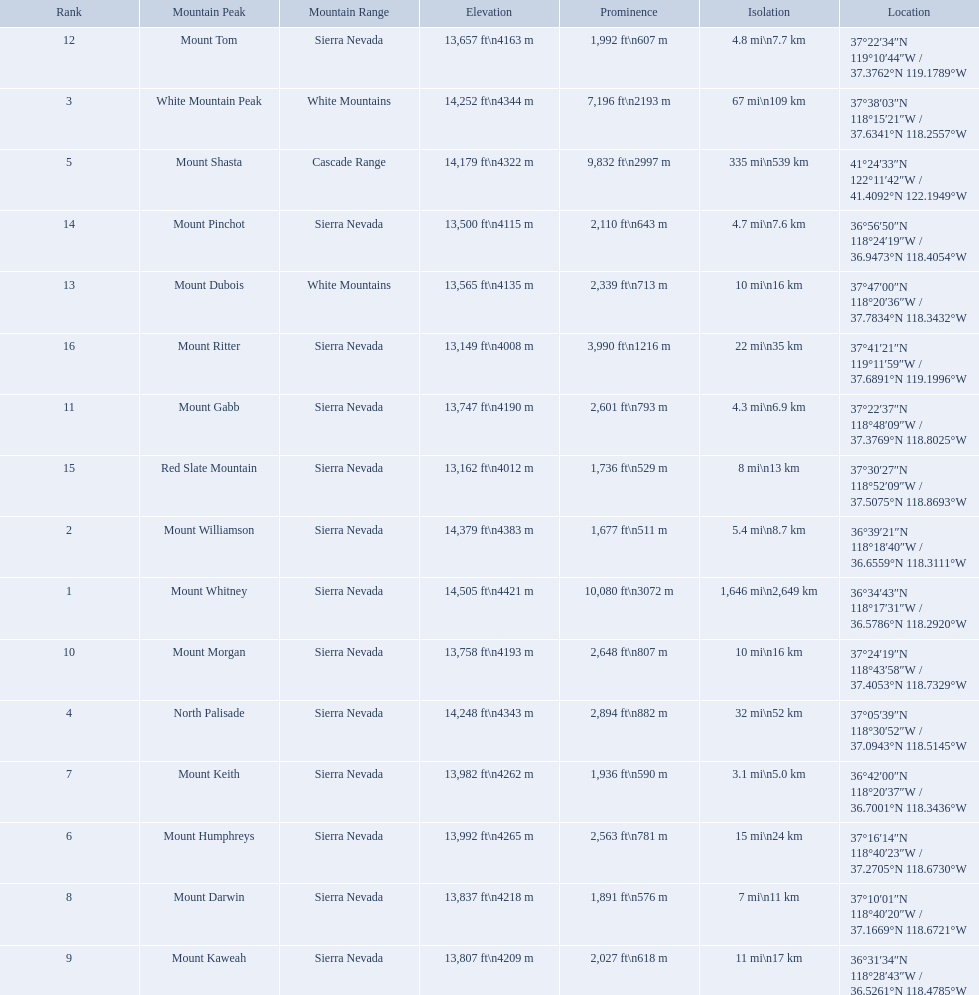What are the heights of the peaks? 14,505 ft\n4421 m, 14,379 ft\n4383 m, 14,252 ft\n4344 m, 14,248 ft\n4343 m, 14,179 ft\n4322 m, 13,992 ft\n4265 m, 13,982 ft\n4262 m, 13,837 ft\n4218 m, 13,807 ft\n4209 m, 13,758 ft\n4193 m, 13,747 ft\n4190 m, 13,657 ft\n4163 m, 13,565 ft\n4135 m, 13,500 ft\n4115 m, 13,162 ft\n4012 m, 13,149 ft\n4008 m. Which of these heights is tallest? 14,505 ft\n4421 m. What peak is 14,505 feet? Mount Whitney. What are the listed elevations? 14,505 ft\n4421 m, 14,379 ft\n4383 m, 14,252 ft\n4344 m, 14,248 ft\n4343 m, 14,179 ft\n4322 m, 13,992 ft\n4265 m, 13,982 ft\n4262 m, 13,837 ft\n4218 m, 13,807 ft\n4209 m, 13,758 ft\n4193 m, 13,747 ft\n4190 m, 13,657 ft\n4163 m, 13,565 ft\n4135 m, 13,500 ft\n4115 m, 13,162 ft\n4012 m, 13,149 ft\n4008 m. Which of those is 13,149 ft or below? 13,149 ft\n4008 m. To what mountain peak does that value correspond? Mount Ritter. 